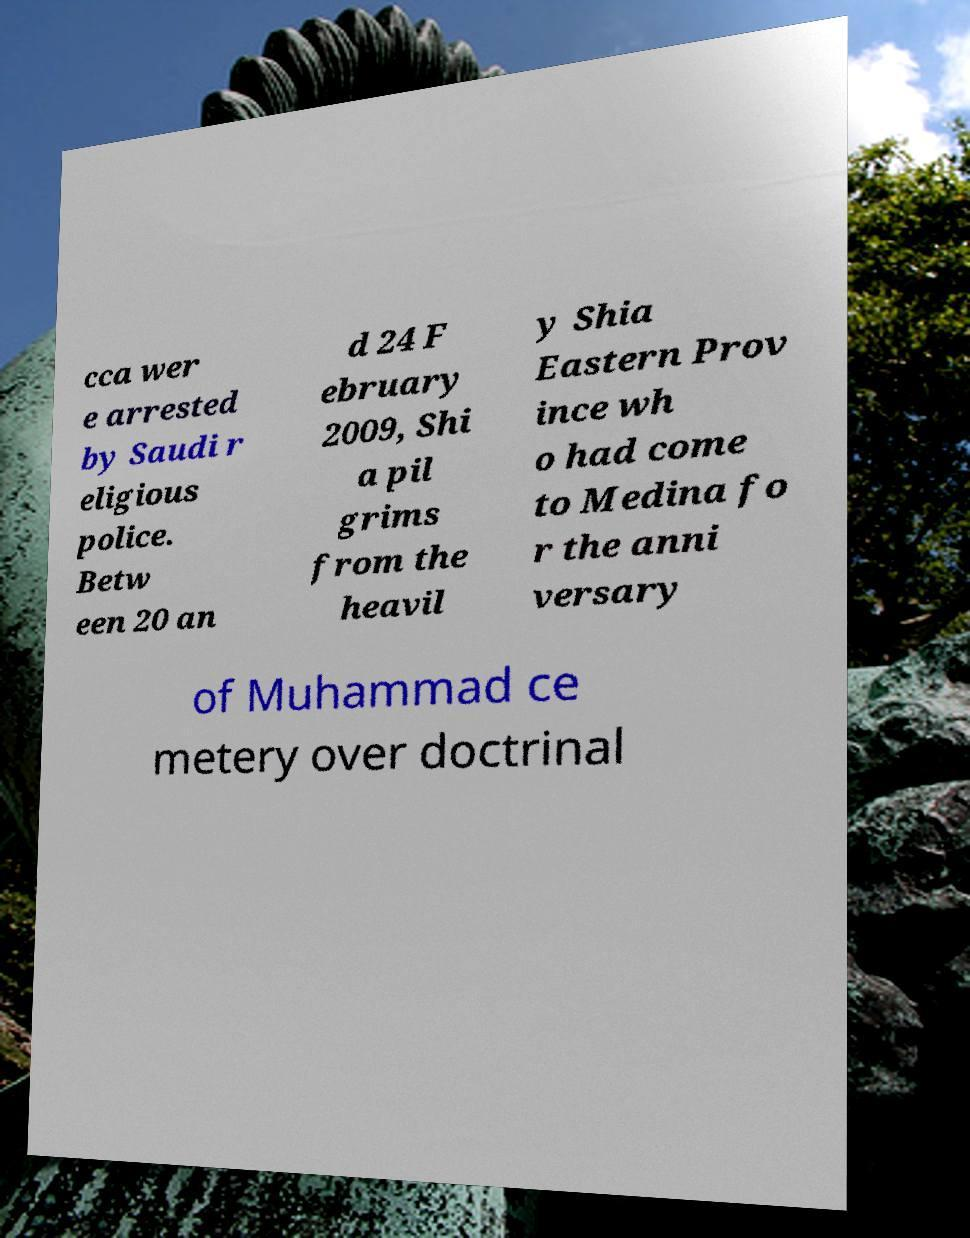Please read and relay the text visible in this image. What does it say? cca wer e arrested by Saudi r eligious police. Betw een 20 an d 24 F ebruary 2009, Shi a pil grims from the heavil y Shia Eastern Prov ince wh o had come to Medina fo r the anni versary of Muhammad ce metery over doctrinal 